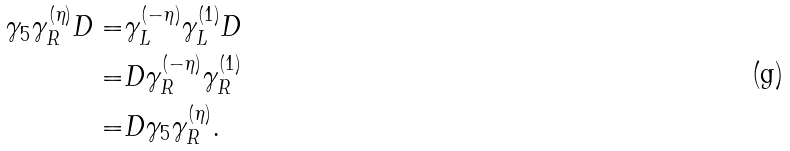Convert formula to latex. <formula><loc_0><loc_0><loc_500><loc_500>\gamma _ { 5 } \gamma _ { R } ^ { ( \eta ) } D = & \gamma _ { L } ^ { ( - \eta ) } \gamma _ { L } ^ { ( 1 ) } D \\ = & D \gamma _ { R } ^ { ( - \eta ) } \gamma _ { R } ^ { ( 1 ) } \\ = & D \gamma _ { 5 } \gamma _ { R } ^ { ( \eta ) } .</formula> 